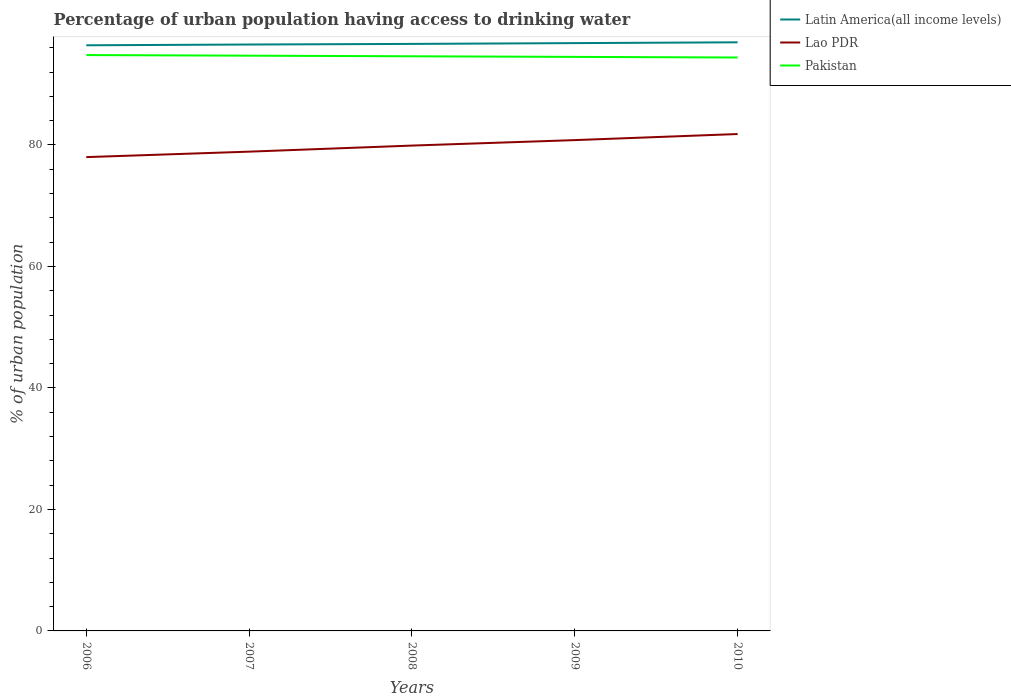Does the line corresponding to Lao PDR intersect with the line corresponding to Latin America(all income levels)?
Offer a very short reply. No. Across all years, what is the maximum percentage of urban population having access to drinking water in Pakistan?
Provide a succinct answer. 94.4. In which year was the percentage of urban population having access to drinking water in Pakistan maximum?
Offer a terse response. 2010. What is the total percentage of urban population having access to drinking water in Latin America(all income levels) in the graph?
Give a very brief answer. -0.1. What is the difference between the highest and the second highest percentage of urban population having access to drinking water in Lao PDR?
Your answer should be compact. 3.8. How many lines are there?
Your answer should be very brief. 3. How many years are there in the graph?
Your response must be concise. 5. What is the difference between two consecutive major ticks on the Y-axis?
Your answer should be very brief. 20. Does the graph contain any zero values?
Your response must be concise. No. How many legend labels are there?
Offer a very short reply. 3. What is the title of the graph?
Give a very brief answer. Percentage of urban population having access to drinking water. What is the label or title of the X-axis?
Your response must be concise. Years. What is the label or title of the Y-axis?
Offer a terse response. % of urban population. What is the % of urban population in Latin America(all income levels) in 2006?
Your response must be concise. 96.41. What is the % of urban population in Lao PDR in 2006?
Offer a very short reply. 78. What is the % of urban population in Pakistan in 2006?
Provide a succinct answer. 94.8. What is the % of urban population in Latin America(all income levels) in 2007?
Ensure brevity in your answer.  96.54. What is the % of urban population of Lao PDR in 2007?
Offer a terse response. 78.9. What is the % of urban population in Pakistan in 2007?
Make the answer very short. 94.7. What is the % of urban population of Latin America(all income levels) in 2008?
Offer a terse response. 96.64. What is the % of urban population of Lao PDR in 2008?
Make the answer very short. 79.9. What is the % of urban population of Pakistan in 2008?
Your answer should be very brief. 94.6. What is the % of urban population of Latin America(all income levels) in 2009?
Make the answer very short. 96.77. What is the % of urban population in Lao PDR in 2009?
Keep it short and to the point. 80.8. What is the % of urban population of Pakistan in 2009?
Keep it short and to the point. 94.5. What is the % of urban population of Latin America(all income levels) in 2010?
Give a very brief answer. 96.9. What is the % of urban population of Lao PDR in 2010?
Offer a very short reply. 81.8. What is the % of urban population in Pakistan in 2010?
Your response must be concise. 94.4. Across all years, what is the maximum % of urban population in Latin America(all income levels)?
Ensure brevity in your answer.  96.9. Across all years, what is the maximum % of urban population in Lao PDR?
Your answer should be very brief. 81.8. Across all years, what is the maximum % of urban population of Pakistan?
Your answer should be very brief. 94.8. Across all years, what is the minimum % of urban population of Latin America(all income levels)?
Keep it short and to the point. 96.41. Across all years, what is the minimum % of urban population of Pakistan?
Offer a very short reply. 94.4. What is the total % of urban population of Latin America(all income levels) in the graph?
Offer a very short reply. 483.25. What is the total % of urban population in Lao PDR in the graph?
Make the answer very short. 399.4. What is the total % of urban population in Pakistan in the graph?
Offer a terse response. 473. What is the difference between the % of urban population in Latin America(all income levels) in 2006 and that in 2007?
Your response must be concise. -0.13. What is the difference between the % of urban population in Pakistan in 2006 and that in 2007?
Give a very brief answer. 0.1. What is the difference between the % of urban population of Latin America(all income levels) in 2006 and that in 2008?
Keep it short and to the point. -0.22. What is the difference between the % of urban population of Lao PDR in 2006 and that in 2008?
Offer a terse response. -1.9. What is the difference between the % of urban population of Pakistan in 2006 and that in 2008?
Your answer should be very brief. 0.2. What is the difference between the % of urban population of Latin America(all income levels) in 2006 and that in 2009?
Offer a terse response. -0.36. What is the difference between the % of urban population in Pakistan in 2006 and that in 2009?
Provide a succinct answer. 0.3. What is the difference between the % of urban population in Latin America(all income levels) in 2006 and that in 2010?
Ensure brevity in your answer.  -0.49. What is the difference between the % of urban population in Latin America(all income levels) in 2007 and that in 2008?
Your answer should be compact. -0.1. What is the difference between the % of urban population in Lao PDR in 2007 and that in 2008?
Make the answer very short. -1. What is the difference between the % of urban population in Latin America(all income levels) in 2007 and that in 2009?
Ensure brevity in your answer.  -0.23. What is the difference between the % of urban population of Lao PDR in 2007 and that in 2009?
Give a very brief answer. -1.9. What is the difference between the % of urban population in Pakistan in 2007 and that in 2009?
Offer a terse response. 0.2. What is the difference between the % of urban population in Latin America(all income levels) in 2007 and that in 2010?
Provide a succinct answer. -0.36. What is the difference between the % of urban population of Pakistan in 2007 and that in 2010?
Offer a terse response. 0.3. What is the difference between the % of urban population in Latin America(all income levels) in 2008 and that in 2009?
Your answer should be compact. -0.13. What is the difference between the % of urban population of Latin America(all income levels) in 2008 and that in 2010?
Give a very brief answer. -0.26. What is the difference between the % of urban population in Latin America(all income levels) in 2009 and that in 2010?
Your answer should be compact. -0.13. What is the difference between the % of urban population in Pakistan in 2009 and that in 2010?
Provide a short and direct response. 0.1. What is the difference between the % of urban population in Latin America(all income levels) in 2006 and the % of urban population in Lao PDR in 2007?
Offer a very short reply. 17.51. What is the difference between the % of urban population of Latin America(all income levels) in 2006 and the % of urban population of Pakistan in 2007?
Your answer should be compact. 1.71. What is the difference between the % of urban population in Lao PDR in 2006 and the % of urban population in Pakistan in 2007?
Make the answer very short. -16.7. What is the difference between the % of urban population of Latin America(all income levels) in 2006 and the % of urban population of Lao PDR in 2008?
Give a very brief answer. 16.51. What is the difference between the % of urban population in Latin America(all income levels) in 2006 and the % of urban population in Pakistan in 2008?
Your answer should be very brief. 1.81. What is the difference between the % of urban population in Lao PDR in 2006 and the % of urban population in Pakistan in 2008?
Provide a short and direct response. -16.6. What is the difference between the % of urban population in Latin America(all income levels) in 2006 and the % of urban population in Lao PDR in 2009?
Keep it short and to the point. 15.61. What is the difference between the % of urban population of Latin America(all income levels) in 2006 and the % of urban population of Pakistan in 2009?
Ensure brevity in your answer.  1.91. What is the difference between the % of urban population in Lao PDR in 2006 and the % of urban population in Pakistan in 2009?
Offer a very short reply. -16.5. What is the difference between the % of urban population of Latin America(all income levels) in 2006 and the % of urban population of Lao PDR in 2010?
Give a very brief answer. 14.61. What is the difference between the % of urban population of Latin America(all income levels) in 2006 and the % of urban population of Pakistan in 2010?
Your answer should be compact. 2.01. What is the difference between the % of urban population in Lao PDR in 2006 and the % of urban population in Pakistan in 2010?
Ensure brevity in your answer.  -16.4. What is the difference between the % of urban population of Latin America(all income levels) in 2007 and the % of urban population of Lao PDR in 2008?
Your response must be concise. 16.64. What is the difference between the % of urban population in Latin America(all income levels) in 2007 and the % of urban population in Pakistan in 2008?
Offer a terse response. 1.94. What is the difference between the % of urban population in Lao PDR in 2007 and the % of urban population in Pakistan in 2008?
Provide a short and direct response. -15.7. What is the difference between the % of urban population in Latin America(all income levels) in 2007 and the % of urban population in Lao PDR in 2009?
Ensure brevity in your answer.  15.74. What is the difference between the % of urban population of Latin America(all income levels) in 2007 and the % of urban population of Pakistan in 2009?
Ensure brevity in your answer.  2.04. What is the difference between the % of urban population of Lao PDR in 2007 and the % of urban population of Pakistan in 2009?
Ensure brevity in your answer.  -15.6. What is the difference between the % of urban population in Latin America(all income levels) in 2007 and the % of urban population in Lao PDR in 2010?
Provide a short and direct response. 14.74. What is the difference between the % of urban population of Latin America(all income levels) in 2007 and the % of urban population of Pakistan in 2010?
Offer a very short reply. 2.14. What is the difference between the % of urban population of Lao PDR in 2007 and the % of urban population of Pakistan in 2010?
Your answer should be compact. -15.5. What is the difference between the % of urban population of Latin America(all income levels) in 2008 and the % of urban population of Lao PDR in 2009?
Offer a terse response. 15.84. What is the difference between the % of urban population in Latin America(all income levels) in 2008 and the % of urban population in Pakistan in 2009?
Your answer should be compact. 2.14. What is the difference between the % of urban population in Lao PDR in 2008 and the % of urban population in Pakistan in 2009?
Provide a succinct answer. -14.6. What is the difference between the % of urban population of Latin America(all income levels) in 2008 and the % of urban population of Lao PDR in 2010?
Offer a very short reply. 14.84. What is the difference between the % of urban population of Latin America(all income levels) in 2008 and the % of urban population of Pakistan in 2010?
Your answer should be very brief. 2.24. What is the difference between the % of urban population of Latin America(all income levels) in 2009 and the % of urban population of Lao PDR in 2010?
Your answer should be very brief. 14.97. What is the difference between the % of urban population of Latin America(all income levels) in 2009 and the % of urban population of Pakistan in 2010?
Your response must be concise. 2.37. What is the average % of urban population in Latin America(all income levels) per year?
Offer a terse response. 96.65. What is the average % of urban population in Lao PDR per year?
Provide a short and direct response. 79.88. What is the average % of urban population in Pakistan per year?
Ensure brevity in your answer.  94.6. In the year 2006, what is the difference between the % of urban population of Latin America(all income levels) and % of urban population of Lao PDR?
Ensure brevity in your answer.  18.41. In the year 2006, what is the difference between the % of urban population in Latin America(all income levels) and % of urban population in Pakistan?
Your answer should be compact. 1.61. In the year 2006, what is the difference between the % of urban population in Lao PDR and % of urban population in Pakistan?
Make the answer very short. -16.8. In the year 2007, what is the difference between the % of urban population of Latin America(all income levels) and % of urban population of Lao PDR?
Provide a succinct answer. 17.64. In the year 2007, what is the difference between the % of urban population of Latin America(all income levels) and % of urban population of Pakistan?
Your response must be concise. 1.84. In the year 2007, what is the difference between the % of urban population of Lao PDR and % of urban population of Pakistan?
Provide a succinct answer. -15.8. In the year 2008, what is the difference between the % of urban population of Latin America(all income levels) and % of urban population of Lao PDR?
Ensure brevity in your answer.  16.74. In the year 2008, what is the difference between the % of urban population of Latin America(all income levels) and % of urban population of Pakistan?
Offer a very short reply. 2.04. In the year 2008, what is the difference between the % of urban population in Lao PDR and % of urban population in Pakistan?
Ensure brevity in your answer.  -14.7. In the year 2009, what is the difference between the % of urban population of Latin America(all income levels) and % of urban population of Lao PDR?
Provide a short and direct response. 15.97. In the year 2009, what is the difference between the % of urban population in Latin America(all income levels) and % of urban population in Pakistan?
Offer a very short reply. 2.27. In the year 2009, what is the difference between the % of urban population of Lao PDR and % of urban population of Pakistan?
Keep it short and to the point. -13.7. In the year 2010, what is the difference between the % of urban population in Latin America(all income levels) and % of urban population in Lao PDR?
Offer a terse response. 15.1. In the year 2010, what is the difference between the % of urban population of Latin America(all income levels) and % of urban population of Pakistan?
Make the answer very short. 2.5. In the year 2010, what is the difference between the % of urban population of Lao PDR and % of urban population of Pakistan?
Offer a very short reply. -12.6. What is the ratio of the % of urban population in Latin America(all income levels) in 2006 to that in 2007?
Provide a succinct answer. 1. What is the ratio of the % of urban population in Lao PDR in 2006 to that in 2007?
Provide a succinct answer. 0.99. What is the ratio of the % of urban population in Pakistan in 2006 to that in 2007?
Give a very brief answer. 1. What is the ratio of the % of urban population of Lao PDR in 2006 to that in 2008?
Ensure brevity in your answer.  0.98. What is the ratio of the % of urban population in Latin America(all income levels) in 2006 to that in 2009?
Provide a succinct answer. 1. What is the ratio of the % of urban population in Lao PDR in 2006 to that in 2009?
Give a very brief answer. 0.97. What is the ratio of the % of urban population in Pakistan in 2006 to that in 2009?
Your response must be concise. 1. What is the ratio of the % of urban population in Lao PDR in 2006 to that in 2010?
Offer a terse response. 0.95. What is the ratio of the % of urban population of Pakistan in 2006 to that in 2010?
Provide a short and direct response. 1. What is the ratio of the % of urban population of Lao PDR in 2007 to that in 2008?
Your answer should be compact. 0.99. What is the ratio of the % of urban population in Latin America(all income levels) in 2007 to that in 2009?
Provide a succinct answer. 1. What is the ratio of the % of urban population in Lao PDR in 2007 to that in 2009?
Keep it short and to the point. 0.98. What is the ratio of the % of urban population in Latin America(all income levels) in 2007 to that in 2010?
Keep it short and to the point. 1. What is the ratio of the % of urban population of Lao PDR in 2007 to that in 2010?
Your response must be concise. 0.96. What is the ratio of the % of urban population in Latin America(all income levels) in 2008 to that in 2009?
Offer a very short reply. 1. What is the ratio of the % of urban population of Lao PDR in 2008 to that in 2009?
Your answer should be very brief. 0.99. What is the ratio of the % of urban population in Pakistan in 2008 to that in 2009?
Your response must be concise. 1. What is the ratio of the % of urban population in Latin America(all income levels) in 2008 to that in 2010?
Offer a very short reply. 1. What is the ratio of the % of urban population in Lao PDR in 2008 to that in 2010?
Offer a terse response. 0.98. What is the ratio of the % of urban population in Latin America(all income levels) in 2009 to that in 2010?
Your response must be concise. 1. What is the ratio of the % of urban population in Lao PDR in 2009 to that in 2010?
Provide a succinct answer. 0.99. What is the difference between the highest and the second highest % of urban population in Latin America(all income levels)?
Offer a terse response. 0.13. What is the difference between the highest and the second highest % of urban population of Lao PDR?
Provide a succinct answer. 1. What is the difference between the highest and the second highest % of urban population in Pakistan?
Provide a short and direct response. 0.1. What is the difference between the highest and the lowest % of urban population of Latin America(all income levels)?
Your answer should be compact. 0.49. What is the difference between the highest and the lowest % of urban population in Pakistan?
Give a very brief answer. 0.4. 